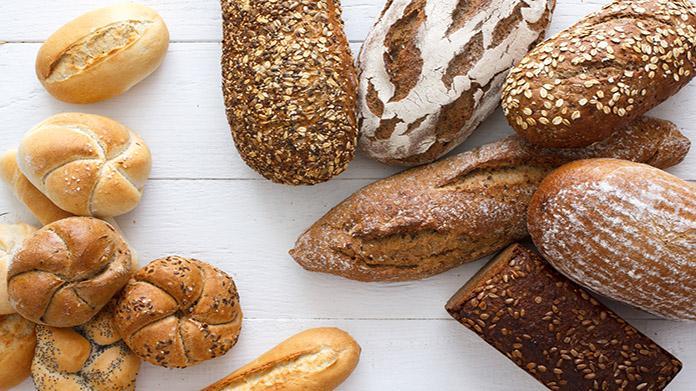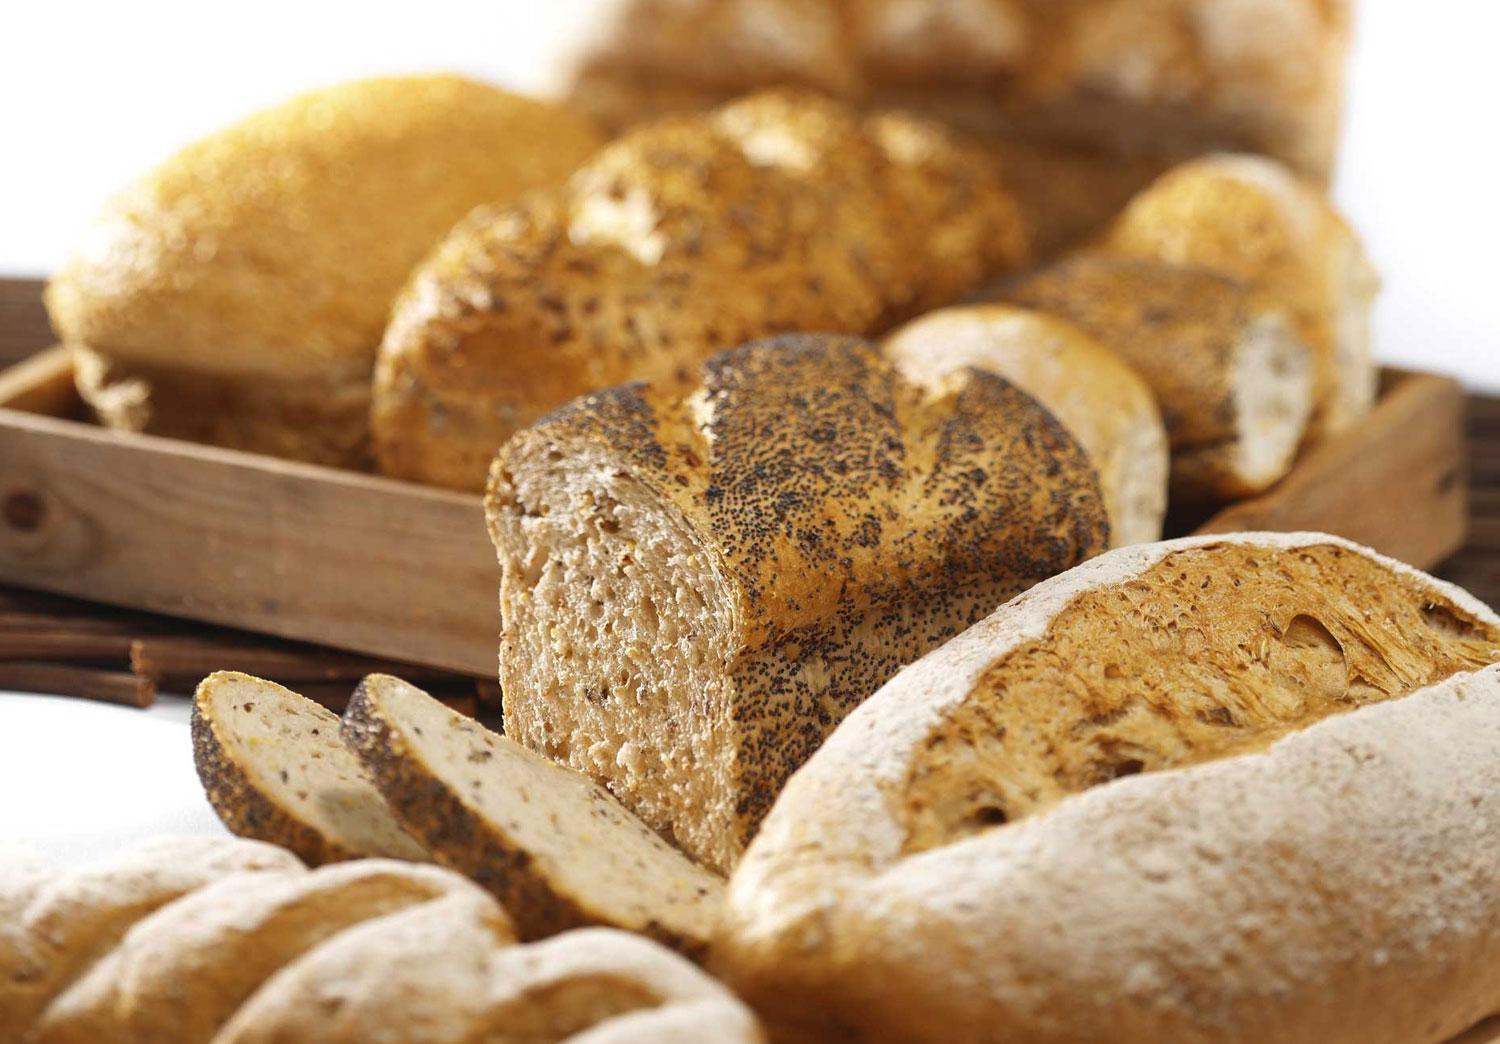The first image is the image on the left, the second image is the image on the right. Given the left and right images, does the statement "Each image contains at least four different bread items, one image shows breads on unpainted wood, and no image includes unbaked dough." hold true? Answer yes or no. Yes. The first image is the image on the left, the second image is the image on the right. Analyze the images presented: Is the assertion "There are kitchen utensils visible in the right image." valid? Answer yes or no. No. 